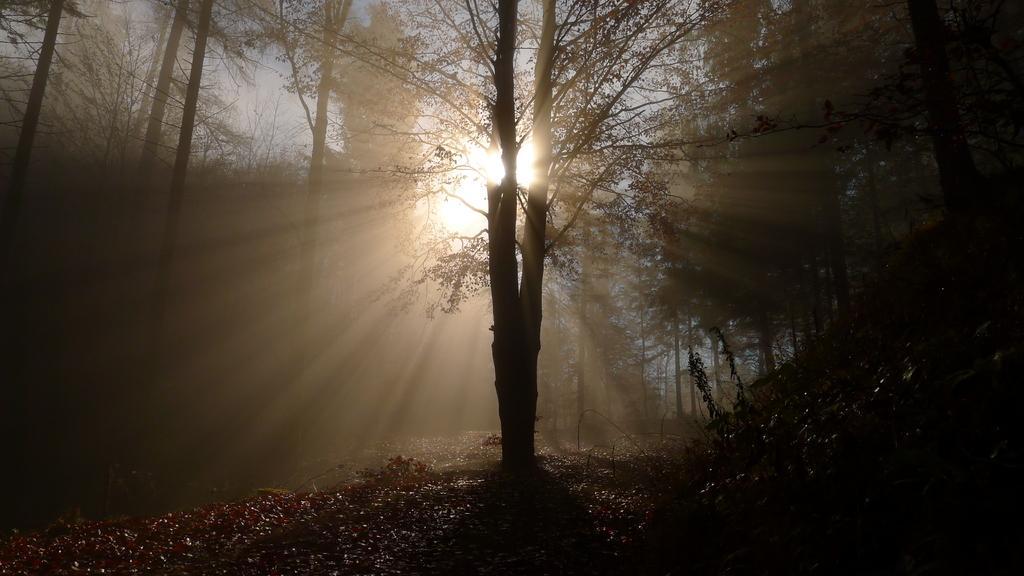Please provide a concise description of this image. It is the picture of beautiful sunrise in the forest, there are many tall trees and the sun is rising from between one of the trees. 